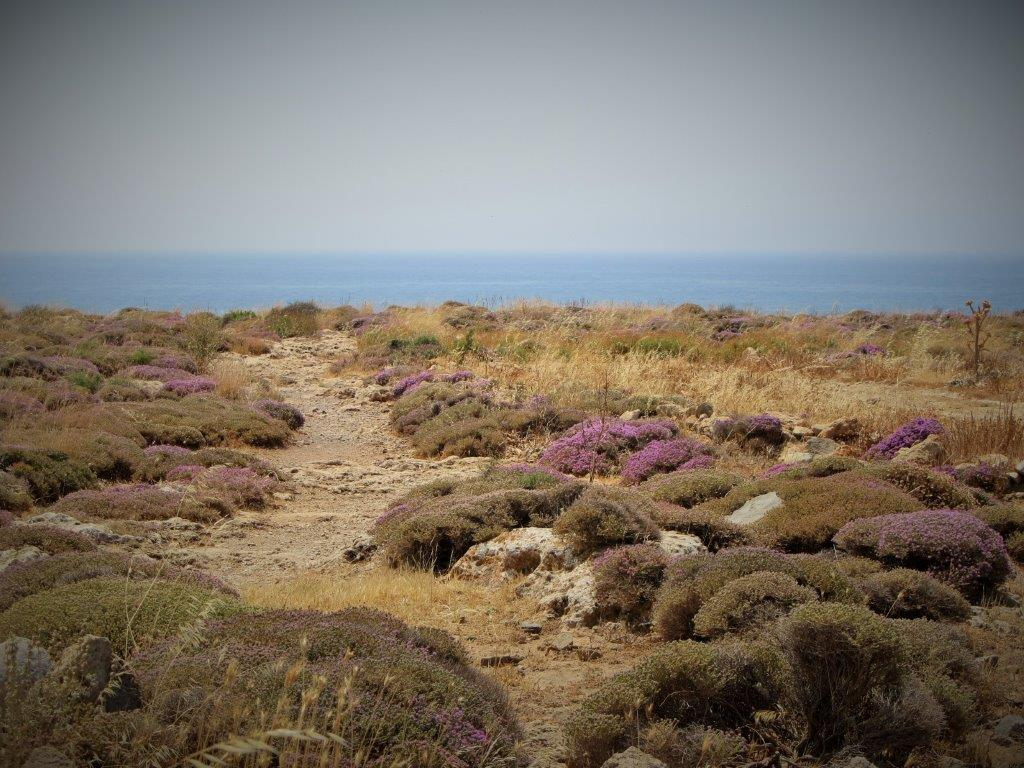What type of terrain is shown in the image? There is land in the image. What can be seen at the bottom of the image? Plants and grass are visible at the bottom of the image. What is located in the background of the image? There is water in the background of the image. What is visible at the top of the image? The sky is visible at the top of the image. What can be observed in the sky? Clouds are present in the sky. How many ants are carrying the can filled with wealth in the image? There are no ants, cans, or any reference to wealth present in the image. 